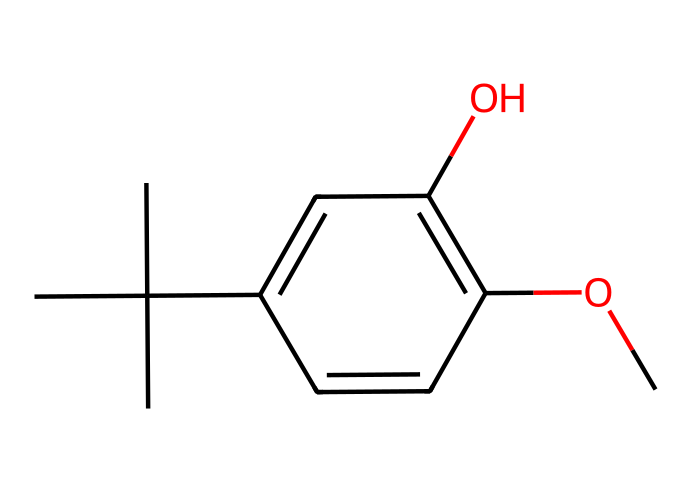What is the molecular formula of BHA? The molecular formula can be determined by counting the different atoms in the chemical structure. In BHA, there are 12 carbon atoms (C), 16 hydrogen atoms (H), and 3 oxygen atoms (O), which gives us the formula C12H16O3.
Answer: C12H16O3 How many hydroxyl (–OH) groups are present in BHA? The presence of the hydroxyl group can be identified from the chemical structure; it is indicated by the symbol 'O' that is directly attached to a carbon atom. There is one –OH group in BHA.
Answer: 1 What type of chemical bond connects the oxygen and hydrogen in the phenolic –OH group? The bond connecting the oxygen and hydrogen in the –OH group is a covalent bond. This bond indicates that the oxygen shares electrons with the hydrogen.
Answer: covalent bond What is the characteristic functional group of phenols that is present in BHA? The characteristic functional group of phenols is the hydroxyl (–OH) group attached to an aromatic ring. In the structure of BHA, this group confirms its classification as a phenolic compound.
Answer: hydroxyl How many carbon atoms are part of the aromatic ring in BHA? The aromatic ring can be identified from the cyclic structure containing alternating double bonds. In the case of BHA, there are 6 carbon atoms in the aromatic ring.
Answer: 6 What is the primary role of BHA in pet food? BHA is primarily used as an antioxidant to prevent the oxidation of fats and oils in pet food, thereby preserving its freshness and extending its shelf life. This preservation is crucial for maintaining the quality of the food.
Answer: antioxidant 